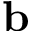Convert formula to latex. <formula><loc_0><loc_0><loc_500><loc_500>b</formula> 